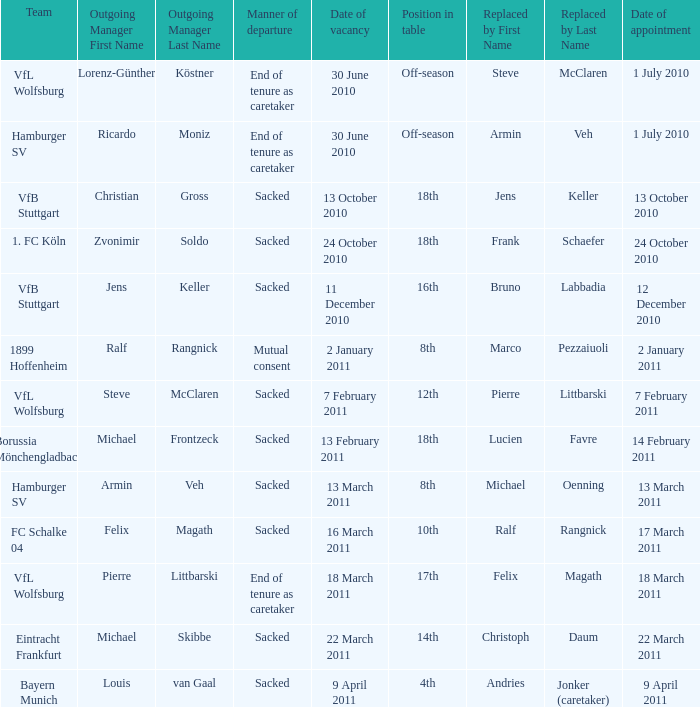When 1. fc köln is the team what is the date of appointment? 24 October 2010. 